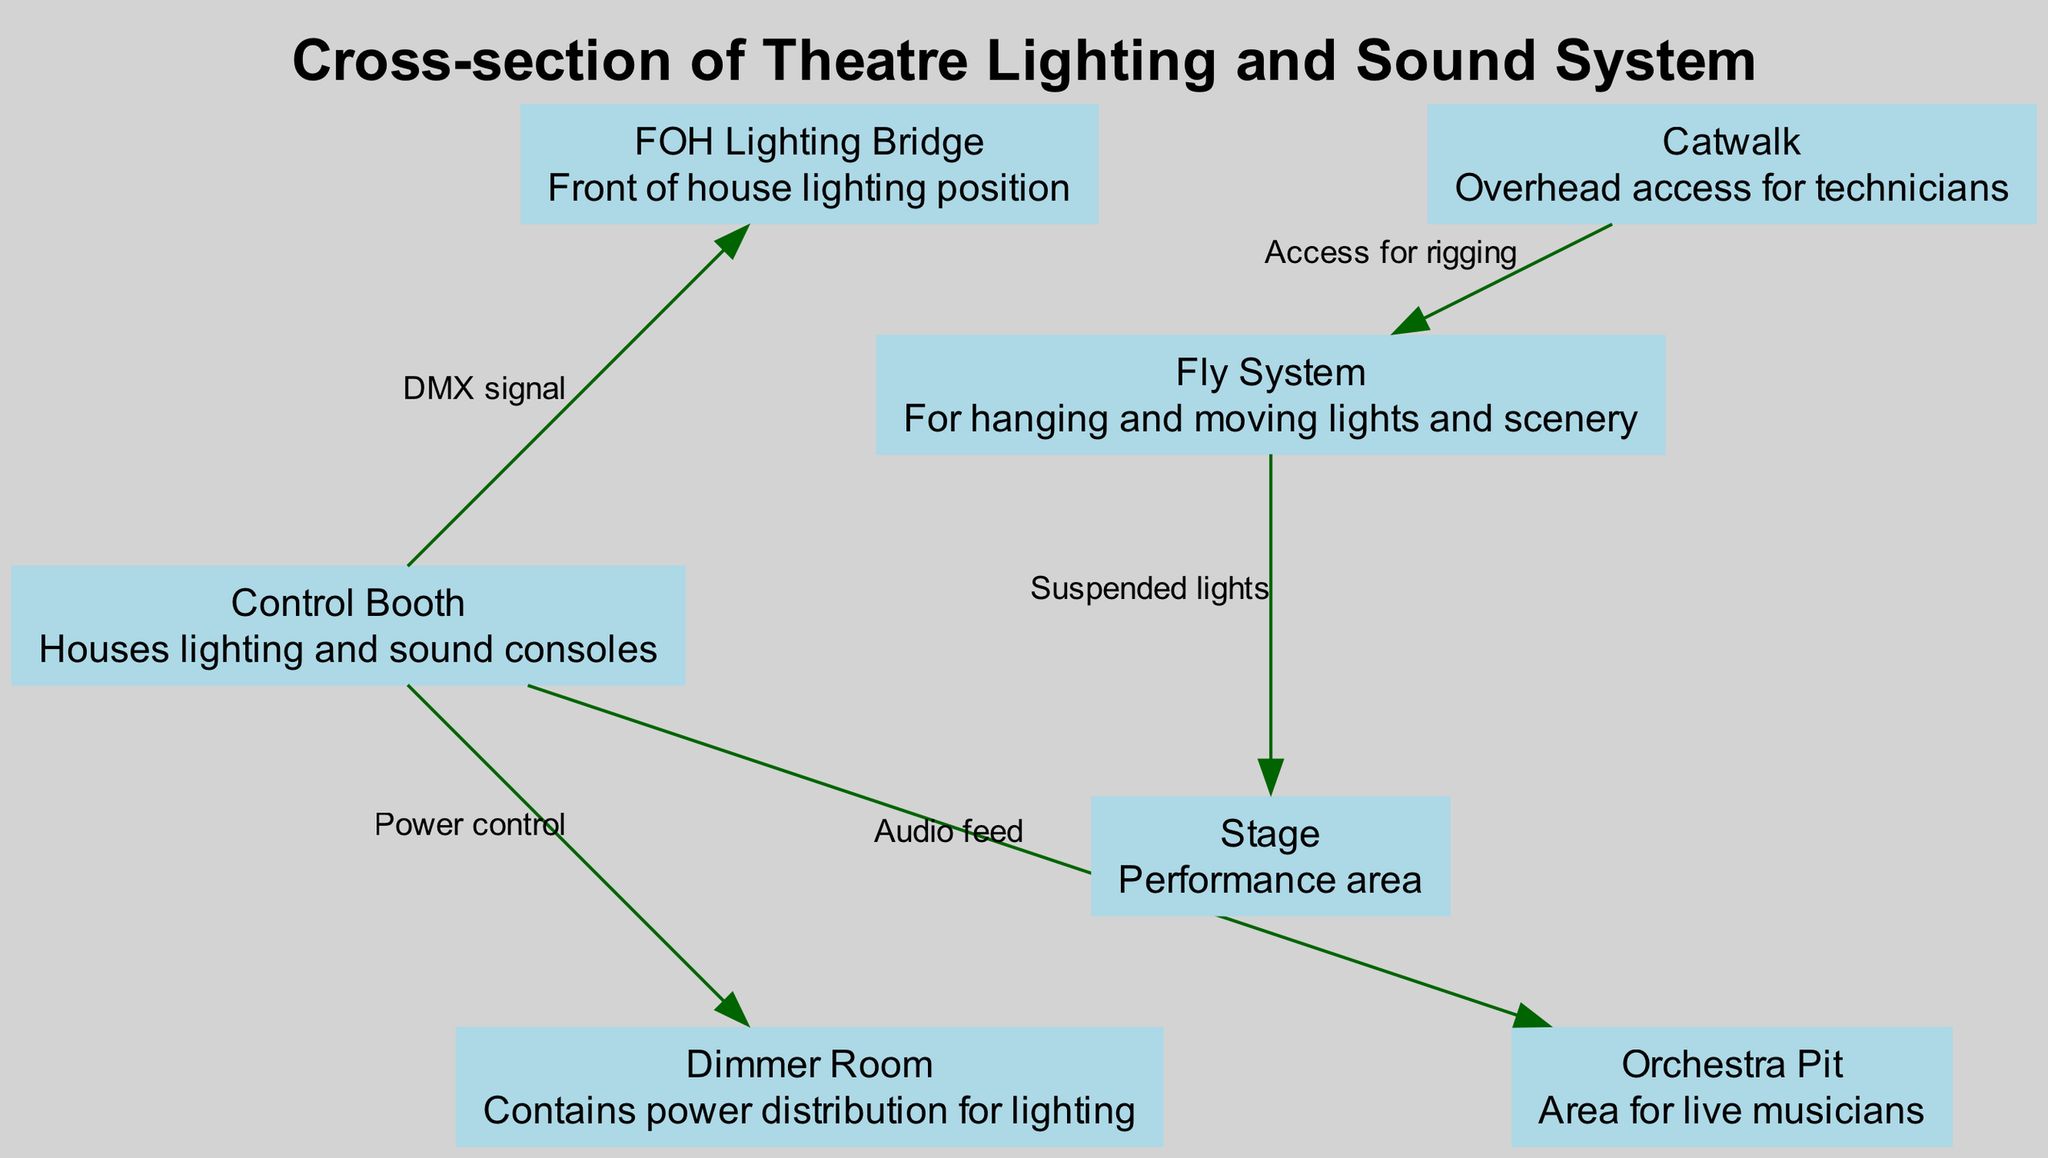What is located in the Control Booth? The Control Booth houses the lighting and sound consoles as per the diagram's description for that node.
Answer: Lighting and sound consoles How many nodes are in the diagram? The diagram lists a total of 7 nodes, each corresponding to different components of the theatre's lighting and sound system.
Answer: 7 What is the connection from the Control Booth to the Dimmer Room labeled as? The connection from the Control Booth to the Dimmer Room is labeled as "Power control," indicating the type of signal being sent.
Answer: Power control Which component has access for rigging? The Catwalk is identified in the diagram as having "Access for rigging," which describes its purpose in the setup.
Answer: Catwalk How many edges are depicted in the diagram? The diagram showcases 5 edges, illustrating the connections between the nodes and representing the flow of signals or access among them.
Answer: 5 What is the purpose of the Fly System? According to the diagram, the Fly System is used for hanging and moving lights and scenery, indicating its role in the theatre.
Answer: Hanging and moving lights and scenery What type of signal does the Control Booth send to the FOH Lighting Bridge? The Control Booth sends a "DMX signal" to the FOH Lighting Bridge, which is a standard type of communication in lighting systems.
Answer: DMX signal Where is the Orchestra Pit situated in relation to the Stage? The Orchestra Pit is located beneath the Stage according to the positional relationships indicated in the diagram, suggesting vertical alignment.
Answer: Beneath the Stage What does the Fly System connect to? The Fly System is directly connected to the Stage, as indicated by the labeled edge "Suspended lights," which signifies the points of connection between them.
Answer: Stage 